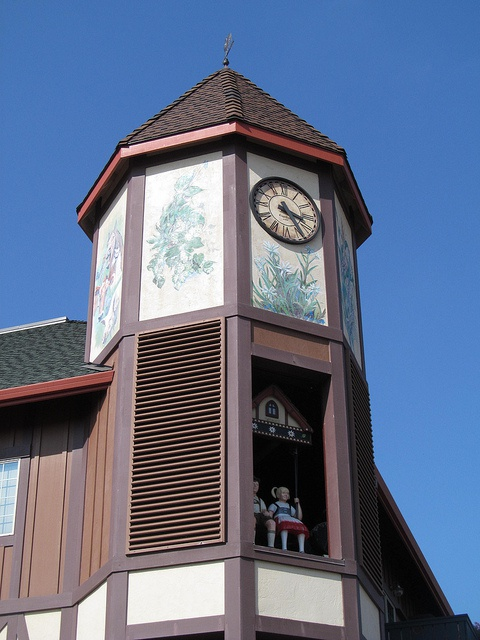Describe the objects in this image and their specific colors. I can see a clock in gray, black, darkgray, and tan tones in this image. 